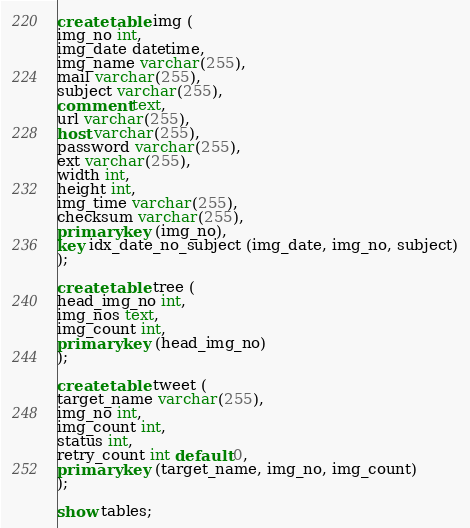<code> <loc_0><loc_0><loc_500><loc_500><_SQL_>create table img (
img_no int,
img_date datetime,
img_name varchar(255),
mail varchar(255),
subject varchar(255),
comment text,
url varchar(255),
host varchar(255),
password varchar(255),
ext varchar(255),
width int,
height int,
img_time varchar(255),
checksum varchar(255),
primary key (img_no),
key idx_date_no_subject (img_date, img_no, subject)
);

create table tree (
head_img_no int,
img_nos text,
img_count int,
primary key (head_img_no)
);

create table tweet (
target_name varchar(255),
img_no int,
img_count int,
status int,
retry_count int default 0,
primary key (target_name, img_no, img_count)
);

show tables;
</code> 